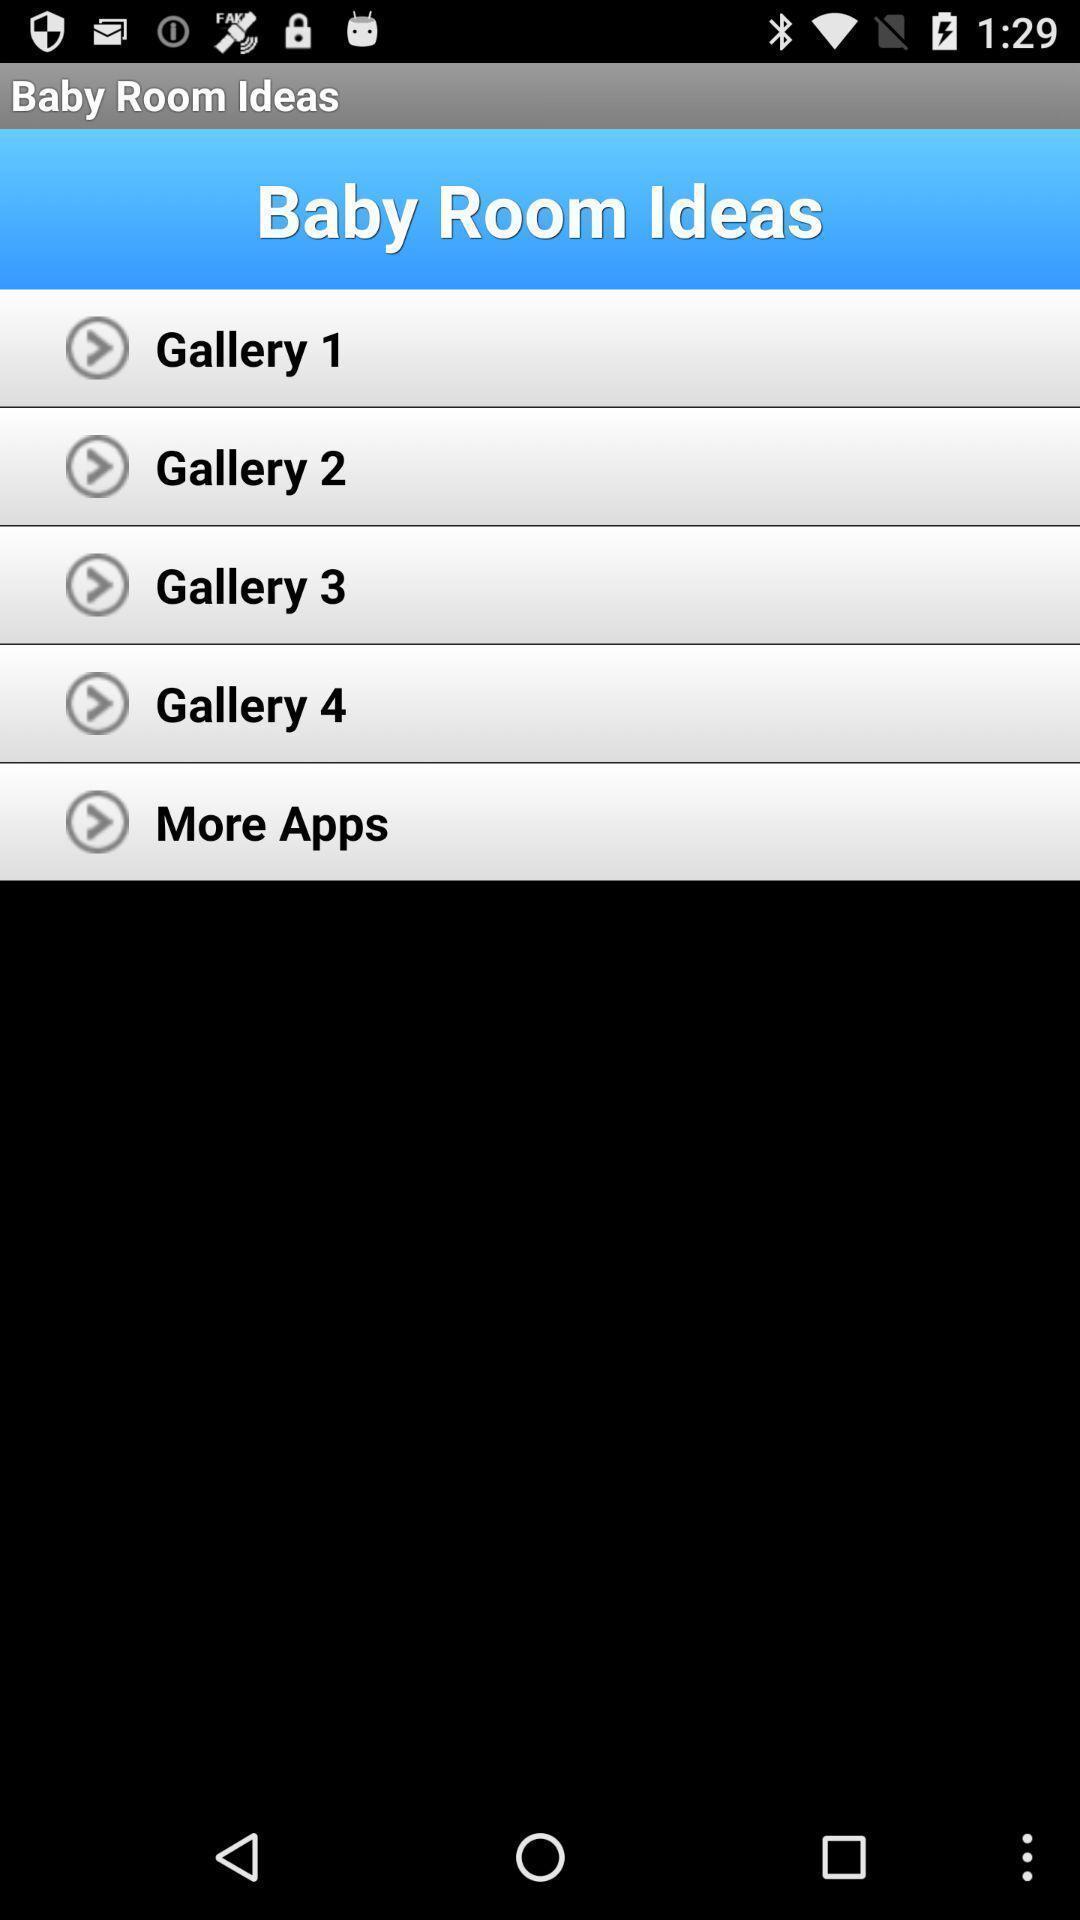What can you discern from this picture? Page displaying with list of different idea options. 